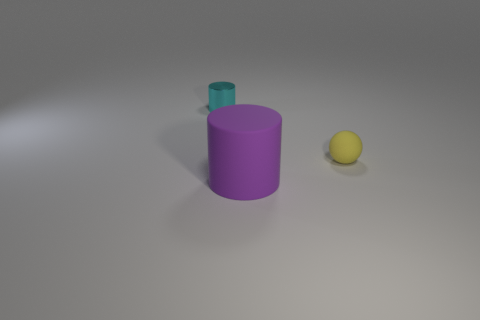Is there anything else that has the same material as the small cyan object?
Offer a terse response. No. Is the tiny object to the right of the tiny cyan cylinder made of the same material as the cyan cylinder?
Provide a short and direct response. No. Is there any other thing that has the same size as the cyan shiny cylinder?
Provide a short and direct response. Yes. Is the number of tiny yellow spheres that are behind the big thing less than the number of small yellow balls that are on the right side of the cyan shiny cylinder?
Your response must be concise. No. Is there any other thing that has the same shape as the small yellow matte thing?
Make the answer very short. No. There is a small object that is in front of the tiny cylinder that is behind the matte sphere; what number of large purple matte cylinders are in front of it?
Offer a very short reply. 1. What number of tiny yellow rubber objects are on the right side of the cyan metallic cylinder?
Offer a terse response. 1. How many cyan objects are the same material as the yellow object?
Keep it short and to the point. 0. What color is the object that is made of the same material as the big purple cylinder?
Your answer should be very brief. Yellow. The tiny thing in front of the cylinder that is on the left side of the cylinder that is on the right side of the small metallic thing is made of what material?
Give a very brief answer. Rubber. 